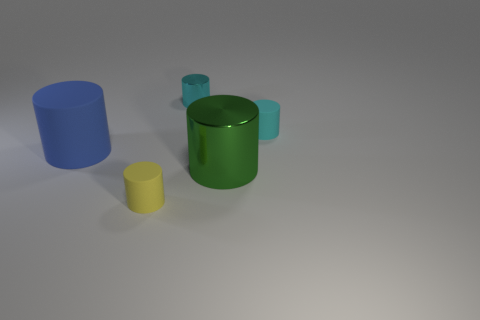Subtract all large rubber cylinders. How many cylinders are left? 4 Subtract all yellow cylinders. How many cylinders are left? 4 Add 4 small cyan matte objects. How many objects exist? 9 Subtract all yellow balls. How many cyan cylinders are left? 2 Subtract 5 cylinders. How many cylinders are left? 0 Subtract all blue cylinders. Subtract all green balls. How many cylinders are left? 4 Subtract all tiny purple metallic objects. Subtract all small shiny cylinders. How many objects are left? 4 Add 5 small cyan objects. How many small cyan objects are left? 7 Add 5 tiny purple metal cylinders. How many tiny purple metal cylinders exist? 5 Subtract 0 brown cylinders. How many objects are left? 5 